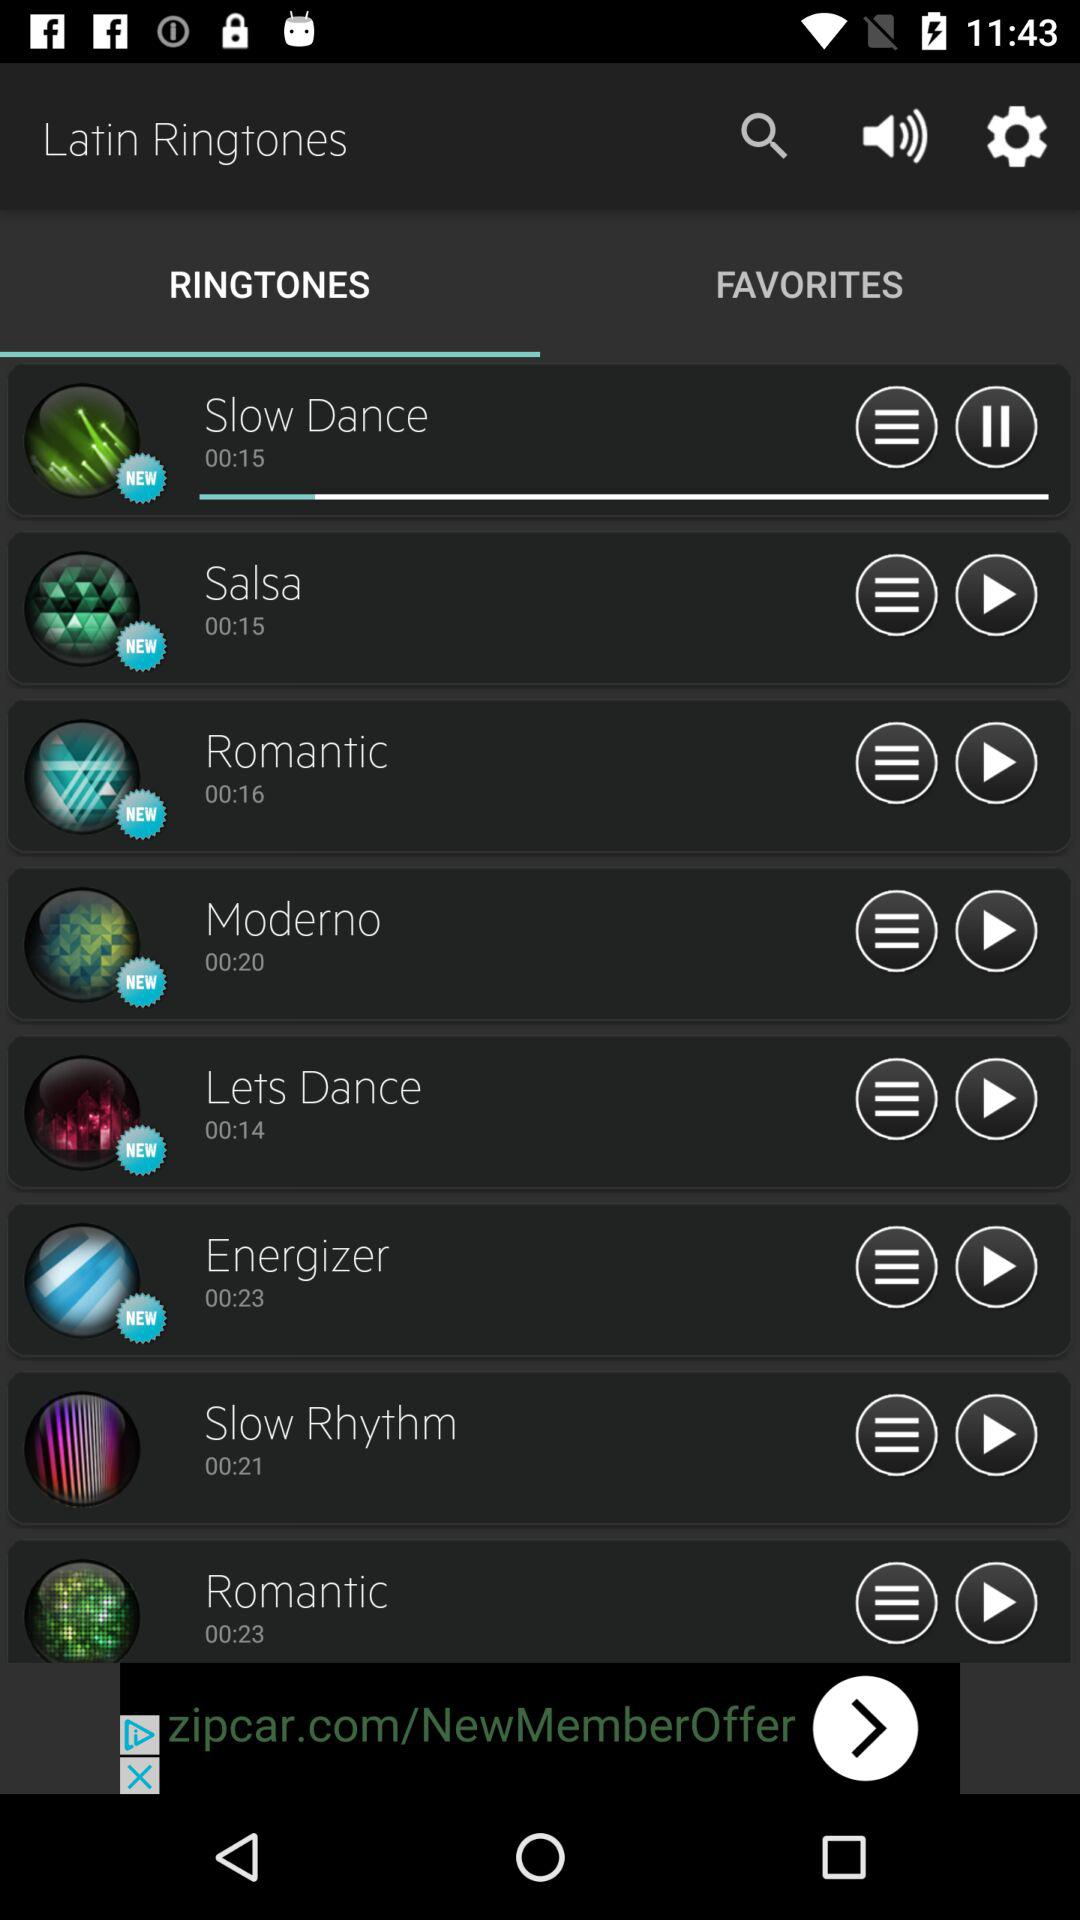00:23 is the duration of which ringtone?
When the provided information is insufficient, respond with <no answer>. <no answer> 